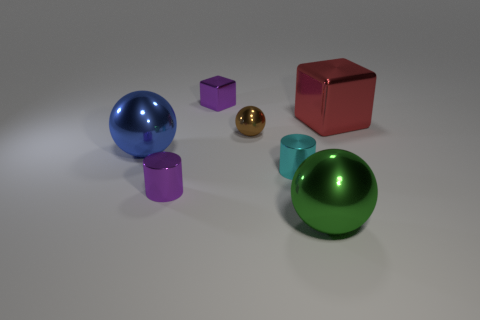Add 2 tiny cyan shiny objects. How many objects exist? 9 Subtract all balls. How many objects are left? 4 Subtract 0 purple spheres. How many objects are left? 7 Subtract all large green metallic objects. Subtract all blue spheres. How many objects are left? 5 Add 7 red metallic cubes. How many red metallic cubes are left? 8 Add 3 purple objects. How many purple objects exist? 5 